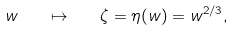Convert formula to latex. <formula><loc_0><loc_0><loc_500><loc_500>w \quad \mapsto \quad \zeta = \eta ( w ) = w ^ { 2 / 3 } ,</formula> 